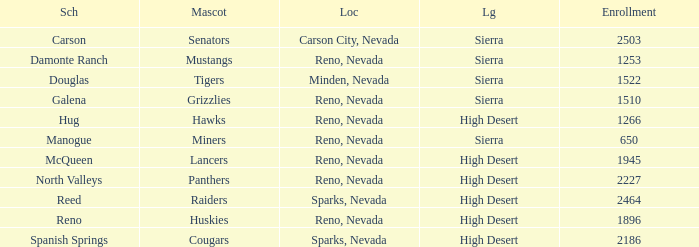What city and state is the Lancers mascot located? Reno, Nevada. 